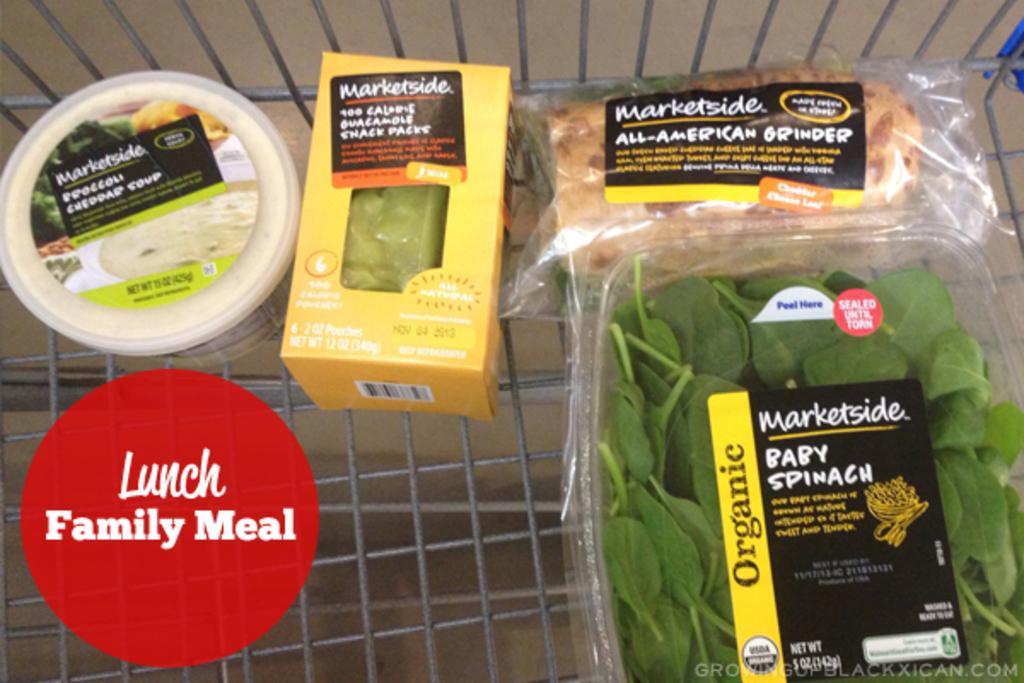Could you give a brief overview of what you see in this image? In this picture we can see a few green leaves and food items in a trolley. There is some text on the right and left side of the image. 